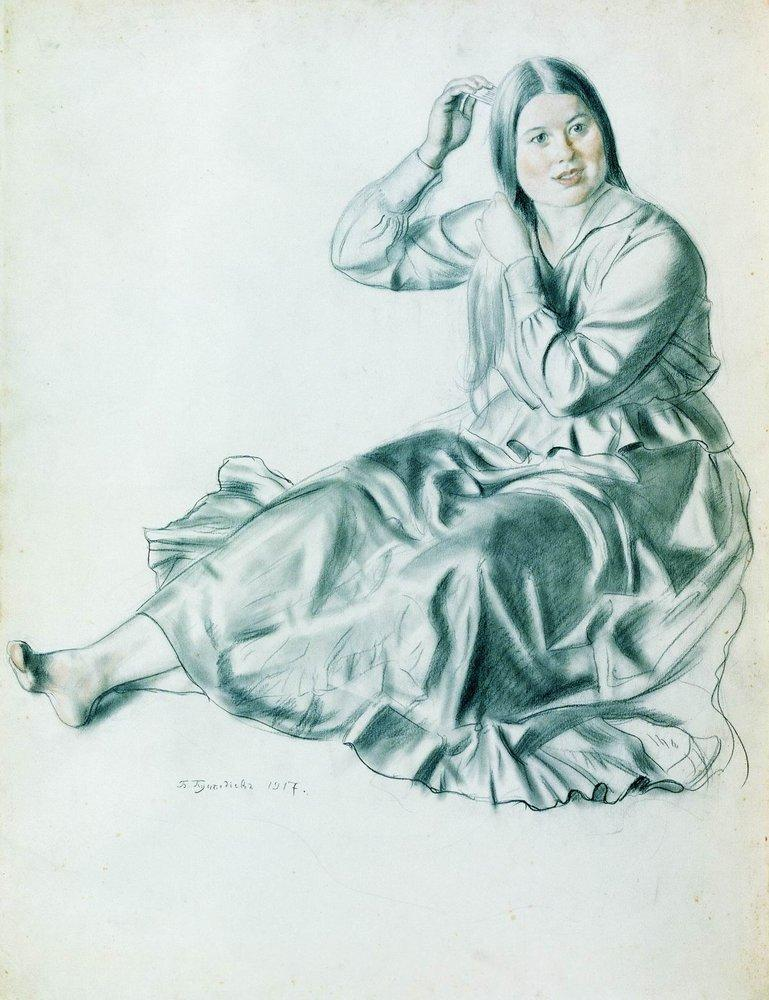What do you think the woman in the image is feeling? The woman in the image appears to be experiencing a sense of calm and contentment. Her relaxed posture and the gentle smile on her face suggest that she might be in a moment of quiet reflection or peace. The act of combing her hair might also indicate a personal and intimate routine, adding to the serene atmosphere of the scene. What could be the significance of the objects around her? In this particular sketch, the focus is primarily on the woman herself, and there are no additional objects depicted around her. This deliberate choice by the artist might signal an emphasis on the subject's inner world and personal moment. The minimalist background ensures that the viewer’s attention is solely concentrated on the woman’s demeanor and the intricate details of her attire and expression. 